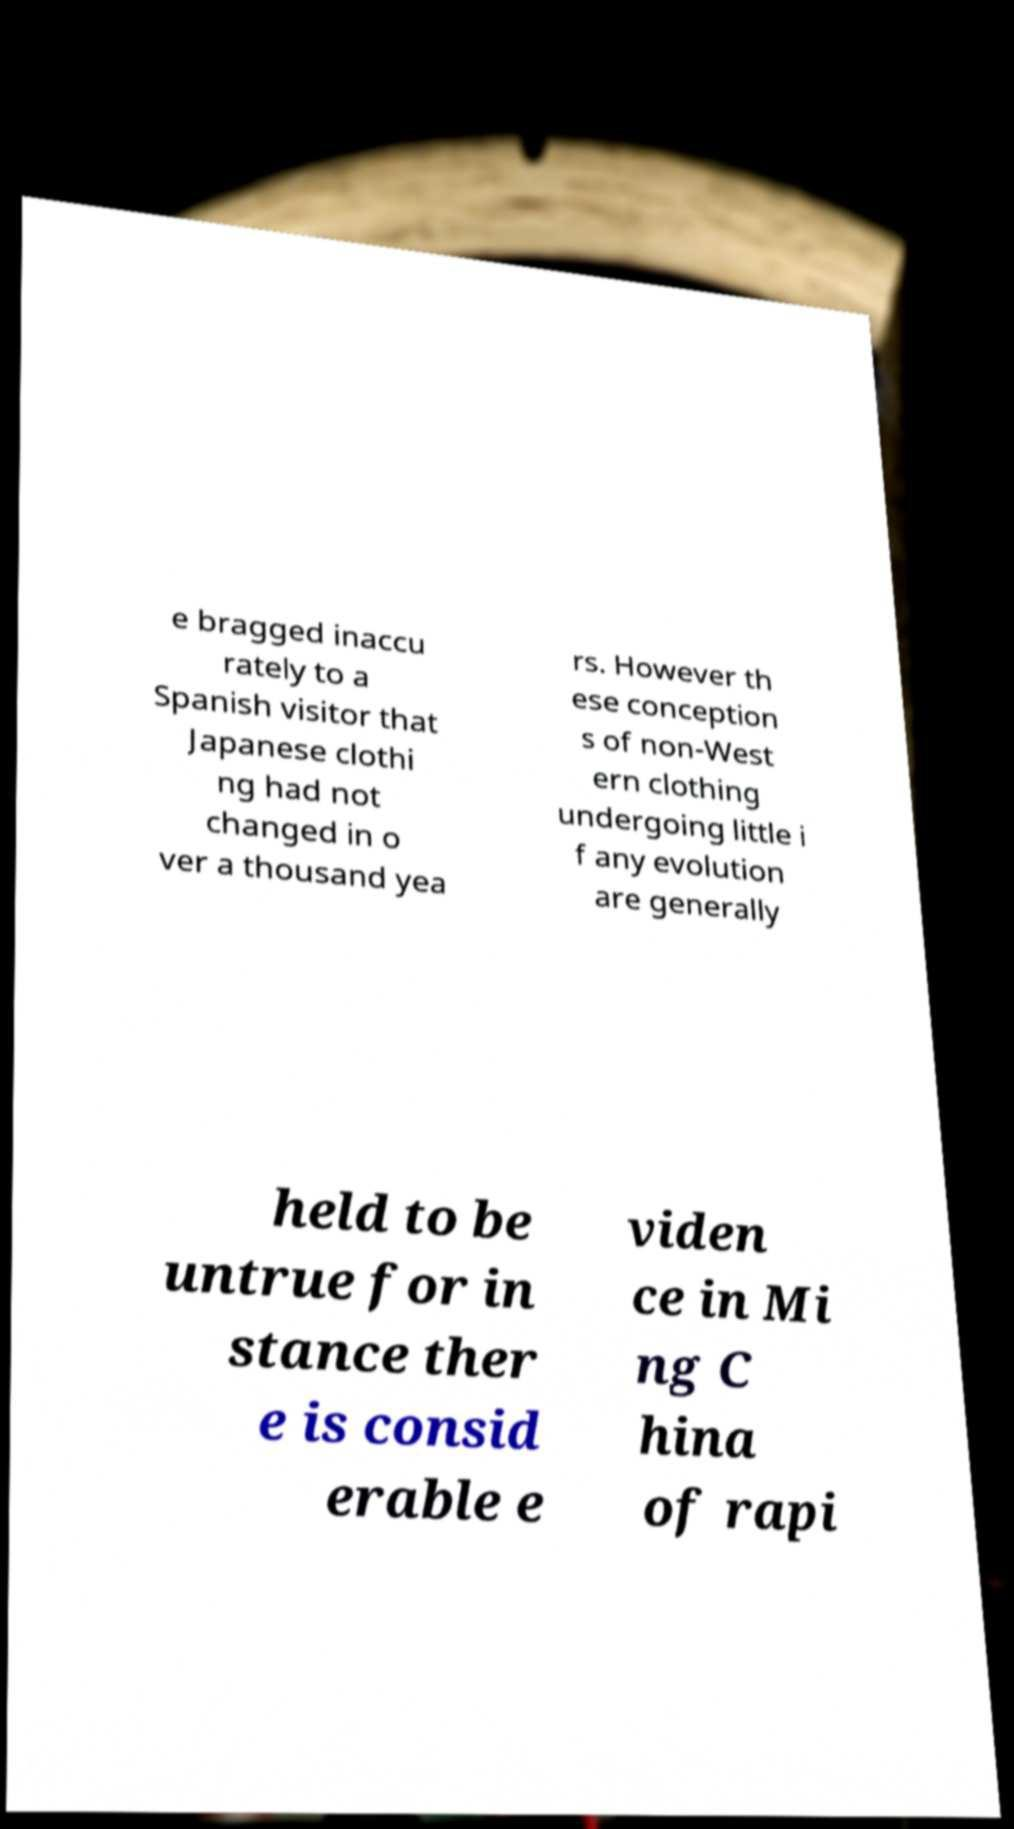Please identify and transcribe the text found in this image. e bragged inaccu rately to a Spanish visitor that Japanese clothi ng had not changed in o ver a thousand yea rs. However th ese conception s of non-West ern clothing undergoing little i f any evolution are generally held to be untrue for in stance ther e is consid erable e viden ce in Mi ng C hina of rapi 